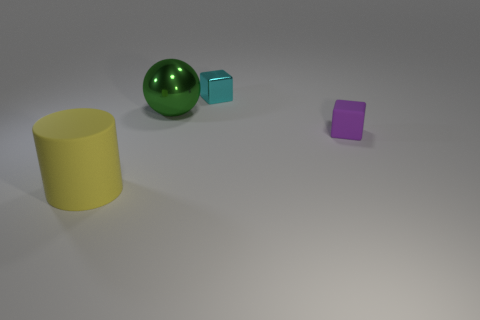What shape is the thing that is both in front of the sphere and on the right side of the large green thing?
Keep it short and to the point. Cube. There is a cyan block that is the same material as the green thing; what size is it?
Your answer should be compact. Small. What number of objects are either matte objects behind the matte cylinder or small blocks in front of the metallic cube?
Provide a short and direct response. 1. There is a block on the left side of the matte block; is it the same size as the tiny purple cube?
Offer a terse response. Yes. There is a large thing that is behind the tiny purple rubber object; what is its color?
Give a very brief answer. Green. There is another small thing that is the same shape as the cyan object; what is its color?
Provide a short and direct response. Purple. There is a purple thing that is on the right side of the metal thing to the left of the small cyan metallic block; what number of metal objects are behind it?
Your answer should be compact. 2. Are there fewer green shiny things that are right of the small metal block than small red metallic spheres?
Ensure brevity in your answer.  No. There is another rubber object that is the same shape as the cyan thing; what is its size?
Ensure brevity in your answer.  Small. How many cyan cubes are made of the same material as the yellow thing?
Offer a very short reply. 0. 